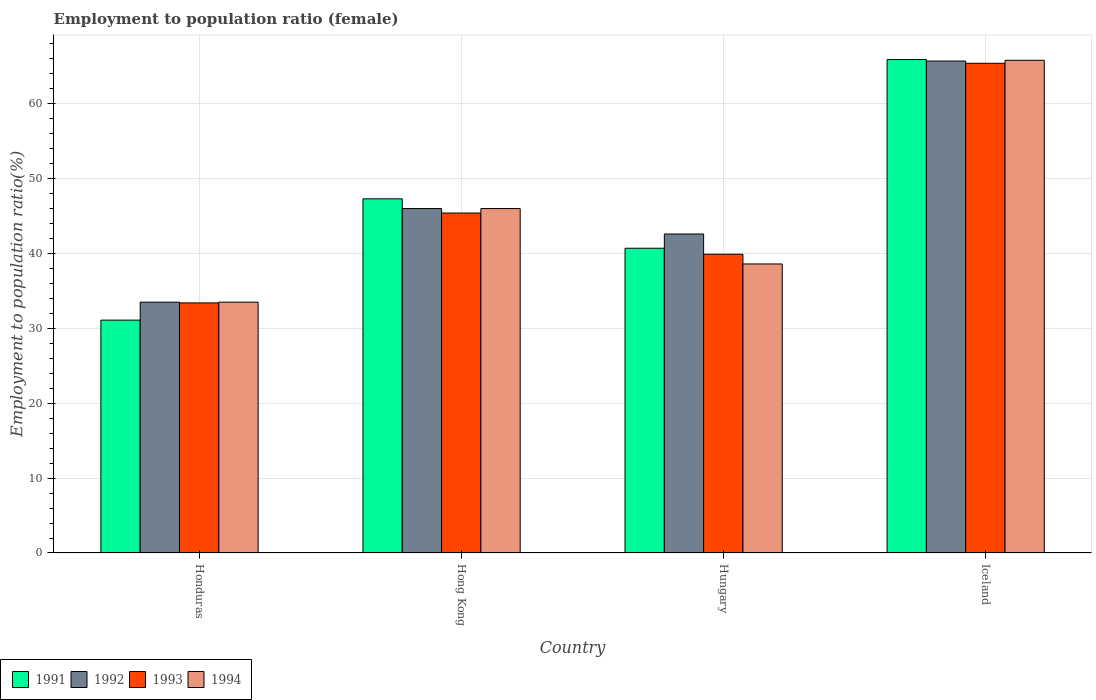How many groups of bars are there?
Your answer should be very brief. 4. Are the number of bars per tick equal to the number of legend labels?
Your answer should be compact. Yes. Are the number of bars on each tick of the X-axis equal?
Offer a very short reply. Yes. How many bars are there on the 1st tick from the left?
Provide a succinct answer. 4. In how many cases, is the number of bars for a given country not equal to the number of legend labels?
Offer a very short reply. 0. What is the employment to population ratio in 1993 in Iceland?
Ensure brevity in your answer.  65.4. Across all countries, what is the maximum employment to population ratio in 1991?
Keep it short and to the point. 65.9. Across all countries, what is the minimum employment to population ratio in 1992?
Your answer should be very brief. 33.5. In which country was the employment to population ratio in 1993 maximum?
Provide a short and direct response. Iceland. In which country was the employment to population ratio in 1993 minimum?
Ensure brevity in your answer.  Honduras. What is the total employment to population ratio in 1991 in the graph?
Your response must be concise. 185. What is the difference between the employment to population ratio in 1992 in Hong Kong and that in Hungary?
Give a very brief answer. 3.4. What is the difference between the employment to population ratio in 1992 in Hungary and the employment to population ratio in 1994 in Hong Kong?
Offer a very short reply. -3.4. What is the average employment to population ratio in 1993 per country?
Your response must be concise. 46.03. What is the difference between the employment to population ratio of/in 1991 and employment to population ratio of/in 1994 in Iceland?
Give a very brief answer. 0.1. In how many countries, is the employment to population ratio in 1994 greater than 26 %?
Your answer should be very brief. 4. What is the ratio of the employment to population ratio in 1993 in Honduras to that in Hungary?
Ensure brevity in your answer.  0.84. What is the difference between the highest and the second highest employment to population ratio in 1993?
Your response must be concise. 20. What is the difference between the highest and the lowest employment to population ratio in 1993?
Offer a terse response. 32. What does the 1st bar from the left in Hungary represents?
Your answer should be very brief. 1991. How many bars are there?
Provide a succinct answer. 16. Are all the bars in the graph horizontal?
Make the answer very short. No. How many countries are there in the graph?
Give a very brief answer. 4. What is the difference between two consecutive major ticks on the Y-axis?
Provide a succinct answer. 10. Are the values on the major ticks of Y-axis written in scientific E-notation?
Provide a succinct answer. No. Does the graph contain any zero values?
Make the answer very short. No. What is the title of the graph?
Provide a short and direct response. Employment to population ratio (female). Does "1980" appear as one of the legend labels in the graph?
Your response must be concise. No. What is the label or title of the X-axis?
Provide a short and direct response. Country. What is the label or title of the Y-axis?
Provide a succinct answer. Employment to population ratio(%). What is the Employment to population ratio(%) in 1991 in Honduras?
Keep it short and to the point. 31.1. What is the Employment to population ratio(%) of 1992 in Honduras?
Your answer should be very brief. 33.5. What is the Employment to population ratio(%) in 1993 in Honduras?
Offer a very short reply. 33.4. What is the Employment to population ratio(%) of 1994 in Honduras?
Provide a short and direct response. 33.5. What is the Employment to population ratio(%) in 1991 in Hong Kong?
Ensure brevity in your answer.  47.3. What is the Employment to population ratio(%) of 1992 in Hong Kong?
Your answer should be very brief. 46. What is the Employment to population ratio(%) in 1993 in Hong Kong?
Keep it short and to the point. 45.4. What is the Employment to population ratio(%) in 1991 in Hungary?
Provide a short and direct response. 40.7. What is the Employment to population ratio(%) in 1992 in Hungary?
Make the answer very short. 42.6. What is the Employment to population ratio(%) of 1993 in Hungary?
Your answer should be compact. 39.9. What is the Employment to population ratio(%) of 1994 in Hungary?
Your answer should be very brief. 38.6. What is the Employment to population ratio(%) of 1991 in Iceland?
Provide a short and direct response. 65.9. What is the Employment to population ratio(%) in 1992 in Iceland?
Provide a short and direct response. 65.7. What is the Employment to population ratio(%) of 1993 in Iceland?
Provide a short and direct response. 65.4. What is the Employment to population ratio(%) of 1994 in Iceland?
Your response must be concise. 65.8. Across all countries, what is the maximum Employment to population ratio(%) of 1991?
Your answer should be very brief. 65.9. Across all countries, what is the maximum Employment to population ratio(%) of 1992?
Keep it short and to the point. 65.7. Across all countries, what is the maximum Employment to population ratio(%) in 1993?
Offer a terse response. 65.4. Across all countries, what is the maximum Employment to population ratio(%) in 1994?
Your answer should be very brief. 65.8. Across all countries, what is the minimum Employment to population ratio(%) in 1991?
Your answer should be very brief. 31.1. Across all countries, what is the minimum Employment to population ratio(%) of 1992?
Your response must be concise. 33.5. Across all countries, what is the minimum Employment to population ratio(%) of 1993?
Ensure brevity in your answer.  33.4. Across all countries, what is the minimum Employment to population ratio(%) in 1994?
Offer a terse response. 33.5. What is the total Employment to population ratio(%) of 1991 in the graph?
Give a very brief answer. 185. What is the total Employment to population ratio(%) of 1992 in the graph?
Keep it short and to the point. 187.8. What is the total Employment to population ratio(%) in 1993 in the graph?
Your answer should be compact. 184.1. What is the total Employment to population ratio(%) in 1994 in the graph?
Your answer should be very brief. 183.9. What is the difference between the Employment to population ratio(%) in 1991 in Honduras and that in Hong Kong?
Provide a succinct answer. -16.2. What is the difference between the Employment to population ratio(%) of 1993 in Honduras and that in Hong Kong?
Keep it short and to the point. -12. What is the difference between the Employment to population ratio(%) of 1992 in Honduras and that in Hungary?
Ensure brevity in your answer.  -9.1. What is the difference between the Employment to population ratio(%) of 1993 in Honduras and that in Hungary?
Keep it short and to the point. -6.5. What is the difference between the Employment to population ratio(%) of 1994 in Honduras and that in Hungary?
Ensure brevity in your answer.  -5.1. What is the difference between the Employment to population ratio(%) of 1991 in Honduras and that in Iceland?
Make the answer very short. -34.8. What is the difference between the Employment to population ratio(%) in 1992 in Honduras and that in Iceland?
Make the answer very short. -32.2. What is the difference between the Employment to population ratio(%) in 1993 in Honduras and that in Iceland?
Offer a very short reply. -32. What is the difference between the Employment to population ratio(%) in 1994 in Honduras and that in Iceland?
Ensure brevity in your answer.  -32.3. What is the difference between the Employment to population ratio(%) of 1991 in Hong Kong and that in Hungary?
Your response must be concise. 6.6. What is the difference between the Employment to population ratio(%) of 1992 in Hong Kong and that in Hungary?
Your answer should be very brief. 3.4. What is the difference between the Employment to population ratio(%) in 1993 in Hong Kong and that in Hungary?
Provide a short and direct response. 5.5. What is the difference between the Employment to population ratio(%) of 1991 in Hong Kong and that in Iceland?
Make the answer very short. -18.6. What is the difference between the Employment to population ratio(%) in 1992 in Hong Kong and that in Iceland?
Offer a very short reply. -19.7. What is the difference between the Employment to population ratio(%) of 1993 in Hong Kong and that in Iceland?
Provide a short and direct response. -20. What is the difference between the Employment to population ratio(%) of 1994 in Hong Kong and that in Iceland?
Give a very brief answer. -19.8. What is the difference between the Employment to population ratio(%) in 1991 in Hungary and that in Iceland?
Your answer should be compact. -25.2. What is the difference between the Employment to population ratio(%) of 1992 in Hungary and that in Iceland?
Give a very brief answer. -23.1. What is the difference between the Employment to population ratio(%) of 1993 in Hungary and that in Iceland?
Your answer should be very brief. -25.5. What is the difference between the Employment to population ratio(%) of 1994 in Hungary and that in Iceland?
Offer a very short reply. -27.2. What is the difference between the Employment to population ratio(%) of 1991 in Honduras and the Employment to population ratio(%) of 1992 in Hong Kong?
Your answer should be compact. -14.9. What is the difference between the Employment to population ratio(%) of 1991 in Honduras and the Employment to population ratio(%) of 1993 in Hong Kong?
Provide a short and direct response. -14.3. What is the difference between the Employment to population ratio(%) of 1991 in Honduras and the Employment to population ratio(%) of 1994 in Hong Kong?
Offer a very short reply. -14.9. What is the difference between the Employment to population ratio(%) of 1992 in Honduras and the Employment to population ratio(%) of 1993 in Hong Kong?
Provide a succinct answer. -11.9. What is the difference between the Employment to population ratio(%) in 1991 in Honduras and the Employment to population ratio(%) in 1993 in Hungary?
Ensure brevity in your answer.  -8.8. What is the difference between the Employment to population ratio(%) of 1991 in Honduras and the Employment to population ratio(%) of 1994 in Hungary?
Your response must be concise. -7.5. What is the difference between the Employment to population ratio(%) in 1992 in Honduras and the Employment to population ratio(%) in 1993 in Hungary?
Ensure brevity in your answer.  -6.4. What is the difference between the Employment to population ratio(%) of 1992 in Honduras and the Employment to population ratio(%) of 1994 in Hungary?
Your answer should be compact. -5.1. What is the difference between the Employment to population ratio(%) in 1993 in Honduras and the Employment to population ratio(%) in 1994 in Hungary?
Your response must be concise. -5.2. What is the difference between the Employment to population ratio(%) in 1991 in Honduras and the Employment to population ratio(%) in 1992 in Iceland?
Offer a very short reply. -34.6. What is the difference between the Employment to population ratio(%) of 1991 in Honduras and the Employment to population ratio(%) of 1993 in Iceland?
Provide a succinct answer. -34.3. What is the difference between the Employment to population ratio(%) in 1991 in Honduras and the Employment to population ratio(%) in 1994 in Iceland?
Keep it short and to the point. -34.7. What is the difference between the Employment to population ratio(%) in 1992 in Honduras and the Employment to population ratio(%) in 1993 in Iceland?
Make the answer very short. -31.9. What is the difference between the Employment to population ratio(%) in 1992 in Honduras and the Employment to population ratio(%) in 1994 in Iceland?
Make the answer very short. -32.3. What is the difference between the Employment to population ratio(%) of 1993 in Honduras and the Employment to population ratio(%) of 1994 in Iceland?
Your answer should be compact. -32.4. What is the difference between the Employment to population ratio(%) of 1992 in Hong Kong and the Employment to population ratio(%) of 1993 in Hungary?
Provide a short and direct response. 6.1. What is the difference between the Employment to population ratio(%) of 1992 in Hong Kong and the Employment to population ratio(%) of 1994 in Hungary?
Give a very brief answer. 7.4. What is the difference between the Employment to population ratio(%) in 1991 in Hong Kong and the Employment to population ratio(%) in 1992 in Iceland?
Provide a succinct answer. -18.4. What is the difference between the Employment to population ratio(%) in 1991 in Hong Kong and the Employment to population ratio(%) in 1993 in Iceland?
Your answer should be very brief. -18.1. What is the difference between the Employment to population ratio(%) in 1991 in Hong Kong and the Employment to population ratio(%) in 1994 in Iceland?
Ensure brevity in your answer.  -18.5. What is the difference between the Employment to population ratio(%) in 1992 in Hong Kong and the Employment to population ratio(%) in 1993 in Iceland?
Offer a terse response. -19.4. What is the difference between the Employment to population ratio(%) in 1992 in Hong Kong and the Employment to population ratio(%) in 1994 in Iceland?
Offer a terse response. -19.8. What is the difference between the Employment to population ratio(%) of 1993 in Hong Kong and the Employment to population ratio(%) of 1994 in Iceland?
Make the answer very short. -20.4. What is the difference between the Employment to population ratio(%) of 1991 in Hungary and the Employment to population ratio(%) of 1992 in Iceland?
Make the answer very short. -25. What is the difference between the Employment to population ratio(%) of 1991 in Hungary and the Employment to population ratio(%) of 1993 in Iceland?
Make the answer very short. -24.7. What is the difference between the Employment to population ratio(%) of 1991 in Hungary and the Employment to population ratio(%) of 1994 in Iceland?
Give a very brief answer. -25.1. What is the difference between the Employment to population ratio(%) of 1992 in Hungary and the Employment to population ratio(%) of 1993 in Iceland?
Ensure brevity in your answer.  -22.8. What is the difference between the Employment to population ratio(%) of 1992 in Hungary and the Employment to population ratio(%) of 1994 in Iceland?
Your answer should be very brief. -23.2. What is the difference between the Employment to population ratio(%) of 1993 in Hungary and the Employment to population ratio(%) of 1994 in Iceland?
Provide a short and direct response. -25.9. What is the average Employment to population ratio(%) of 1991 per country?
Provide a succinct answer. 46.25. What is the average Employment to population ratio(%) of 1992 per country?
Your answer should be compact. 46.95. What is the average Employment to population ratio(%) in 1993 per country?
Keep it short and to the point. 46.02. What is the average Employment to population ratio(%) of 1994 per country?
Give a very brief answer. 45.98. What is the difference between the Employment to population ratio(%) of 1991 and Employment to population ratio(%) of 1994 in Honduras?
Provide a succinct answer. -2.4. What is the difference between the Employment to population ratio(%) of 1992 and Employment to population ratio(%) of 1993 in Honduras?
Provide a succinct answer. 0.1. What is the difference between the Employment to population ratio(%) of 1991 and Employment to population ratio(%) of 1992 in Hong Kong?
Provide a short and direct response. 1.3. What is the difference between the Employment to population ratio(%) in 1992 and Employment to population ratio(%) in 1993 in Hong Kong?
Provide a succinct answer. 0.6. What is the difference between the Employment to population ratio(%) in 1992 and Employment to population ratio(%) in 1994 in Hong Kong?
Your response must be concise. 0. What is the difference between the Employment to population ratio(%) of 1991 and Employment to population ratio(%) of 1994 in Hungary?
Make the answer very short. 2.1. What is the difference between the Employment to population ratio(%) of 1992 and Employment to population ratio(%) of 1994 in Hungary?
Your answer should be very brief. 4. What is the difference between the Employment to population ratio(%) of 1993 and Employment to population ratio(%) of 1994 in Hungary?
Ensure brevity in your answer.  1.3. What is the difference between the Employment to population ratio(%) in 1991 and Employment to population ratio(%) in 1992 in Iceland?
Your answer should be very brief. 0.2. What is the difference between the Employment to population ratio(%) of 1991 and Employment to population ratio(%) of 1994 in Iceland?
Make the answer very short. 0.1. What is the difference between the Employment to population ratio(%) in 1993 and Employment to population ratio(%) in 1994 in Iceland?
Offer a terse response. -0.4. What is the ratio of the Employment to population ratio(%) in 1991 in Honduras to that in Hong Kong?
Give a very brief answer. 0.66. What is the ratio of the Employment to population ratio(%) of 1992 in Honduras to that in Hong Kong?
Offer a terse response. 0.73. What is the ratio of the Employment to population ratio(%) in 1993 in Honduras to that in Hong Kong?
Your answer should be very brief. 0.74. What is the ratio of the Employment to population ratio(%) of 1994 in Honduras to that in Hong Kong?
Give a very brief answer. 0.73. What is the ratio of the Employment to population ratio(%) of 1991 in Honduras to that in Hungary?
Offer a very short reply. 0.76. What is the ratio of the Employment to population ratio(%) in 1992 in Honduras to that in Hungary?
Your response must be concise. 0.79. What is the ratio of the Employment to population ratio(%) in 1993 in Honduras to that in Hungary?
Your answer should be compact. 0.84. What is the ratio of the Employment to population ratio(%) of 1994 in Honduras to that in Hungary?
Keep it short and to the point. 0.87. What is the ratio of the Employment to population ratio(%) in 1991 in Honduras to that in Iceland?
Keep it short and to the point. 0.47. What is the ratio of the Employment to population ratio(%) in 1992 in Honduras to that in Iceland?
Provide a succinct answer. 0.51. What is the ratio of the Employment to population ratio(%) of 1993 in Honduras to that in Iceland?
Your response must be concise. 0.51. What is the ratio of the Employment to population ratio(%) of 1994 in Honduras to that in Iceland?
Your response must be concise. 0.51. What is the ratio of the Employment to population ratio(%) of 1991 in Hong Kong to that in Hungary?
Offer a terse response. 1.16. What is the ratio of the Employment to population ratio(%) of 1992 in Hong Kong to that in Hungary?
Provide a short and direct response. 1.08. What is the ratio of the Employment to population ratio(%) in 1993 in Hong Kong to that in Hungary?
Give a very brief answer. 1.14. What is the ratio of the Employment to population ratio(%) of 1994 in Hong Kong to that in Hungary?
Ensure brevity in your answer.  1.19. What is the ratio of the Employment to population ratio(%) of 1991 in Hong Kong to that in Iceland?
Ensure brevity in your answer.  0.72. What is the ratio of the Employment to population ratio(%) of 1992 in Hong Kong to that in Iceland?
Provide a short and direct response. 0.7. What is the ratio of the Employment to population ratio(%) in 1993 in Hong Kong to that in Iceland?
Ensure brevity in your answer.  0.69. What is the ratio of the Employment to population ratio(%) of 1994 in Hong Kong to that in Iceland?
Keep it short and to the point. 0.7. What is the ratio of the Employment to population ratio(%) in 1991 in Hungary to that in Iceland?
Make the answer very short. 0.62. What is the ratio of the Employment to population ratio(%) in 1992 in Hungary to that in Iceland?
Provide a short and direct response. 0.65. What is the ratio of the Employment to population ratio(%) in 1993 in Hungary to that in Iceland?
Ensure brevity in your answer.  0.61. What is the ratio of the Employment to population ratio(%) of 1994 in Hungary to that in Iceland?
Ensure brevity in your answer.  0.59. What is the difference between the highest and the second highest Employment to population ratio(%) in 1992?
Provide a short and direct response. 19.7. What is the difference between the highest and the second highest Employment to population ratio(%) in 1993?
Make the answer very short. 20. What is the difference between the highest and the second highest Employment to population ratio(%) of 1994?
Your response must be concise. 19.8. What is the difference between the highest and the lowest Employment to population ratio(%) of 1991?
Offer a very short reply. 34.8. What is the difference between the highest and the lowest Employment to population ratio(%) of 1992?
Your answer should be compact. 32.2. What is the difference between the highest and the lowest Employment to population ratio(%) of 1994?
Give a very brief answer. 32.3. 